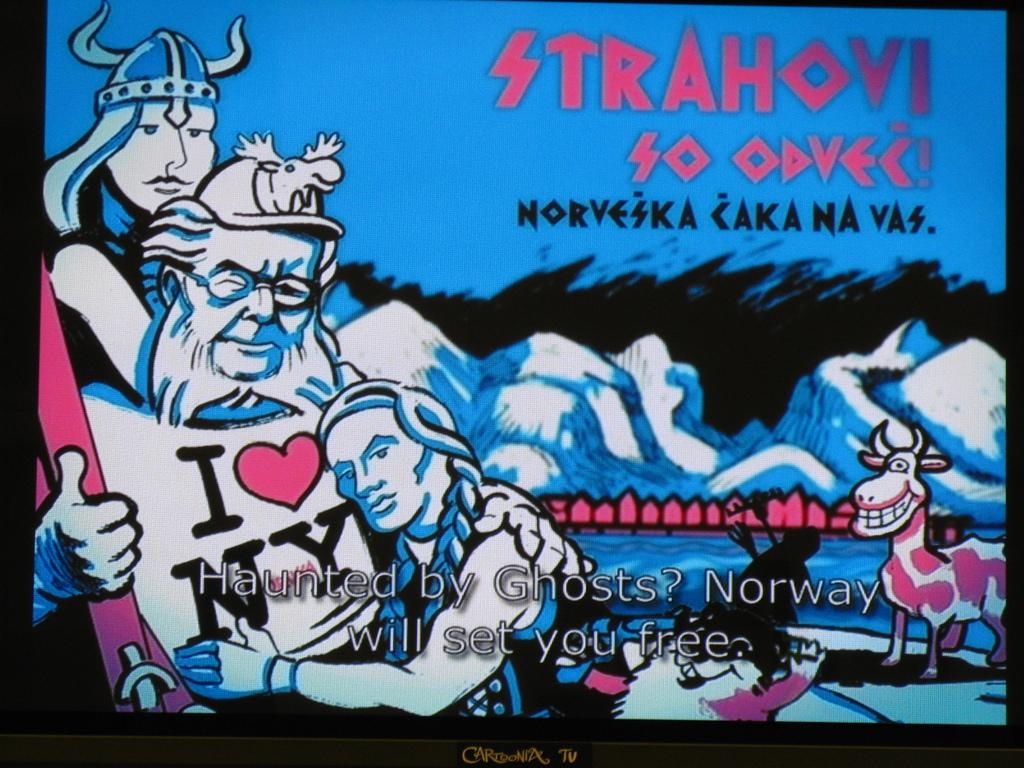What country is this in?
Ensure brevity in your answer.  Norway. I heart what state?
Keep it short and to the point. Ny. 